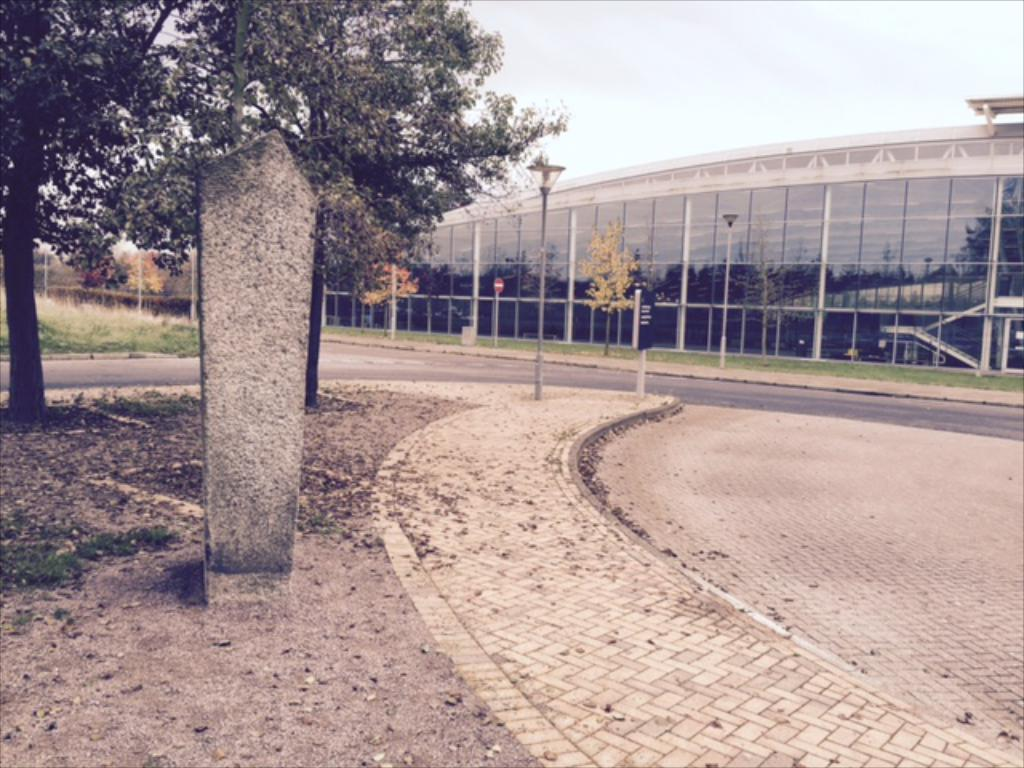What type of surface is visible in the image? There is a floor in the image. What can be seen in the distance in the image? There is a road, at least one building, poles, and trees in the background of the image. What is the opinion of the poison on the event in the image? There is no poison or event present in the image, so it is not possible to determine any opinions about them. 